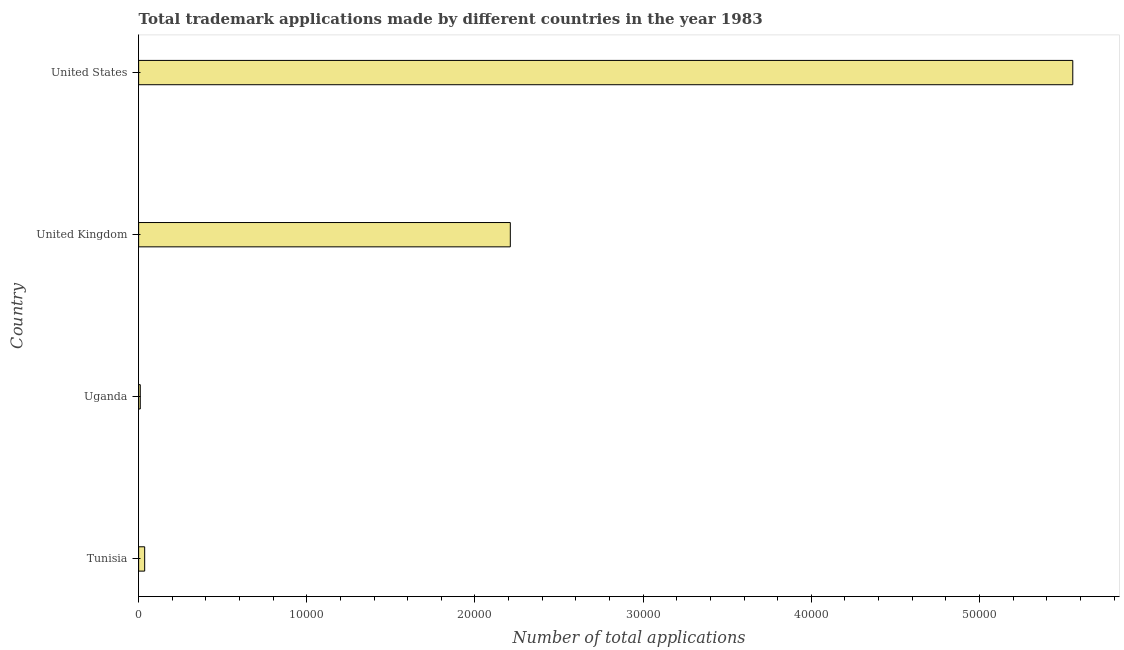Does the graph contain grids?
Provide a short and direct response. No. What is the title of the graph?
Ensure brevity in your answer.  Total trademark applications made by different countries in the year 1983. What is the label or title of the X-axis?
Your response must be concise. Number of total applications. What is the number of trademark applications in United States?
Provide a short and direct response. 5.55e+04. Across all countries, what is the maximum number of trademark applications?
Your response must be concise. 5.55e+04. Across all countries, what is the minimum number of trademark applications?
Your answer should be compact. 97. In which country was the number of trademark applications minimum?
Provide a short and direct response. Uganda. What is the sum of the number of trademark applications?
Keep it short and to the point. 7.81e+04. What is the difference between the number of trademark applications in Tunisia and United Kingdom?
Your response must be concise. -2.17e+04. What is the average number of trademark applications per country?
Your response must be concise. 1.95e+04. What is the median number of trademark applications?
Ensure brevity in your answer.  1.12e+04. What is the ratio of the number of trademark applications in Uganda to that in United States?
Offer a very short reply. 0. What is the difference between the highest and the second highest number of trademark applications?
Provide a short and direct response. 3.34e+04. What is the difference between the highest and the lowest number of trademark applications?
Provide a short and direct response. 5.54e+04. How many countries are there in the graph?
Your answer should be compact. 4. What is the Number of total applications of Tunisia?
Provide a short and direct response. 359. What is the Number of total applications of Uganda?
Provide a succinct answer. 97. What is the Number of total applications in United Kingdom?
Your answer should be very brief. 2.21e+04. What is the Number of total applications in United States?
Ensure brevity in your answer.  5.55e+04. What is the difference between the Number of total applications in Tunisia and Uganda?
Ensure brevity in your answer.  262. What is the difference between the Number of total applications in Tunisia and United Kingdom?
Offer a very short reply. -2.17e+04. What is the difference between the Number of total applications in Tunisia and United States?
Offer a very short reply. -5.52e+04. What is the difference between the Number of total applications in Uganda and United Kingdom?
Offer a very short reply. -2.20e+04. What is the difference between the Number of total applications in Uganda and United States?
Your response must be concise. -5.54e+04. What is the difference between the Number of total applications in United Kingdom and United States?
Provide a short and direct response. -3.34e+04. What is the ratio of the Number of total applications in Tunisia to that in Uganda?
Make the answer very short. 3.7. What is the ratio of the Number of total applications in Tunisia to that in United Kingdom?
Offer a very short reply. 0.02. What is the ratio of the Number of total applications in Tunisia to that in United States?
Make the answer very short. 0.01. What is the ratio of the Number of total applications in Uganda to that in United Kingdom?
Provide a succinct answer. 0. What is the ratio of the Number of total applications in Uganda to that in United States?
Your response must be concise. 0. What is the ratio of the Number of total applications in United Kingdom to that in United States?
Ensure brevity in your answer.  0.4. 